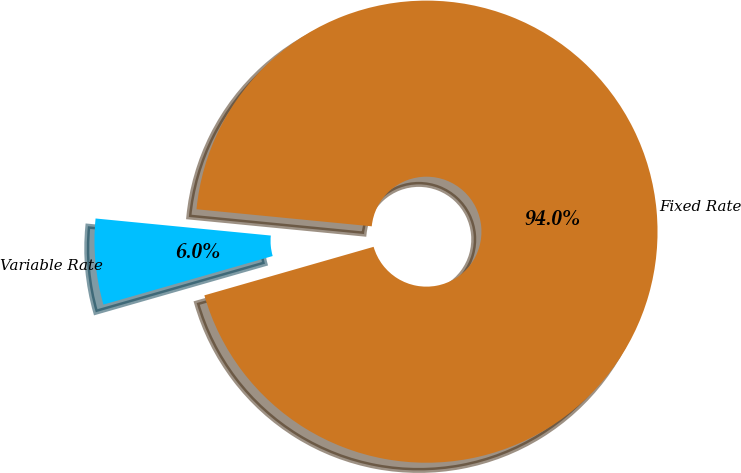Convert chart. <chart><loc_0><loc_0><loc_500><loc_500><pie_chart><fcel>Fixed Rate<fcel>Variable Rate<nl><fcel>94.01%<fcel>5.99%<nl></chart> 